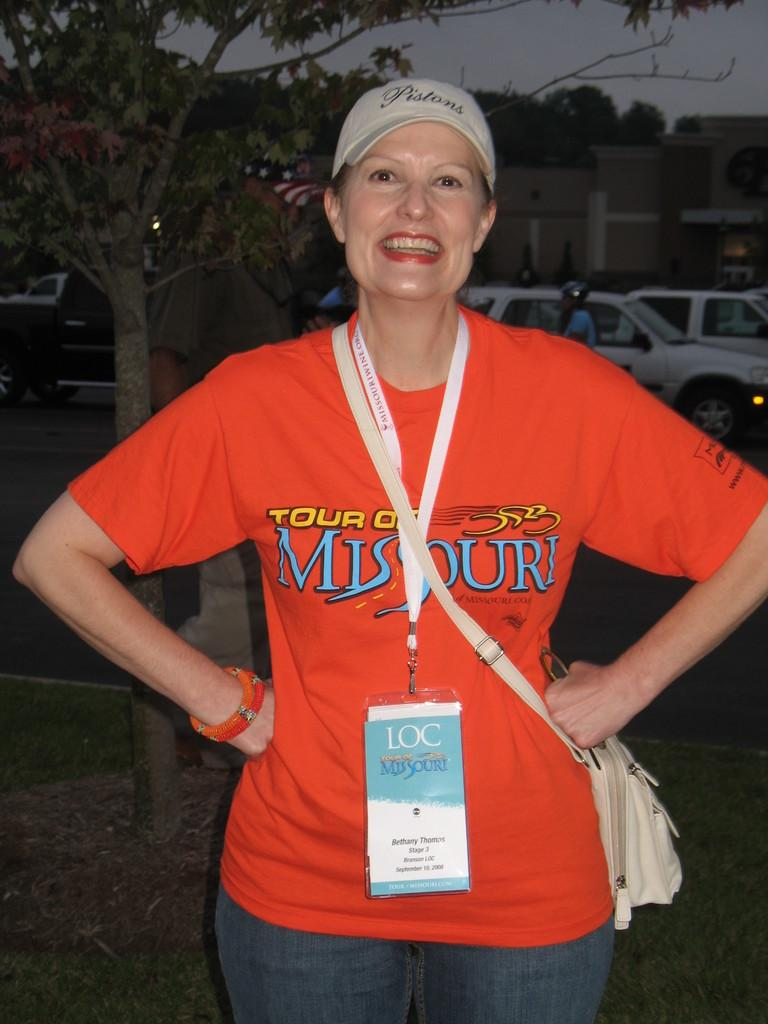Who is present in the image? There is a woman in the image. What is the woman's facial expression? The woman is smiling. What type of accessory is the woman wearing? The woman is wearing a sling bag. What can be seen in the background of the image? There are trees, the sky, buildings, and motor vehicles visible in the background of the image. What color is the balloon in the scene? There is no balloon present in the image. How many rail tracks are visible in the image? There are no rail tracks visible in the image. 